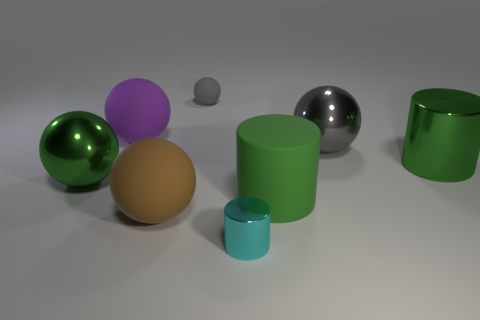Does the large purple matte object have the same shape as the green matte thing?
Keep it short and to the point. No. What is the color of the tiny cylinder?
Offer a very short reply. Cyan. What number of objects are large shiny cylinders or blue metal spheres?
Provide a succinct answer. 1. Is there any other thing that has the same material as the large gray thing?
Offer a very short reply. Yes. Are there fewer purple objects to the right of the purple object than large matte balls?
Your answer should be very brief. Yes. Are there more shiny objects that are on the left side of the brown rubber ball than small things in front of the small cylinder?
Provide a succinct answer. Yes. Is there anything else that is the same color as the rubber cylinder?
Provide a succinct answer. Yes. There is a gray sphere right of the tiny metallic thing; what is it made of?
Your answer should be compact. Metal. Is the size of the green matte cylinder the same as the gray metal object?
Make the answer very short. Yes. What number of other objects are the same size as the purple object?
Provide a succinct answer. 5. 